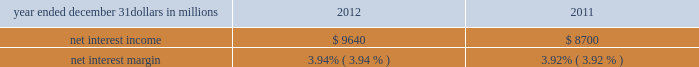Consolidated income statement review our consolidated income statement is presented in item 8 of this report .
Net income for 2012 was $ 3.0 billion compared with $ 3.1 billion for 2011 .
Revenue growth of 8 percent and a decline in the provision for credit losses were more than offset by a 16 percent increase in noninterest expense in 2012 compared to 2011 .
Further detail is included in the net interest income , noninterest income , provision for credit losses and noninterest expense portions of this consolidated income statement review .
Net interest income table 2 : net interest income and net interest margin year ended december 31 dollars in millions 2012 2011 .
Changes in net interest income and margin result from the interaction of the volume and composition of interest-earning assets and related yields , interest-bearing liabilities and related rates paid , and noninterest-bearing sources of funding .
See the statistical information ( unaudited ) 2013 average consolidated balance sheet and net interest analysis and analysis of year-to-year changes in net interest income in item 8 of this report and the discussion of purchase accounting accretion of purchased impaired loans in the consolidated balance sheet review in this item 7 for additional information .
The increase in net interest income in 2012 compared with 2011 was primarily due to the impact of the rbc bank ( usa ) acquisition , organic loan growth and lower funding costs .
Purchase accounting accretion remained stable at $ 1.1 billion in both periods .
The net interest margin was 3.94% ( 3.94 % ) for 2012 and 3.92% ( 3.92 % ) for 2011 .
The increase in the comparison was primarily due to a decrease in the weighted-average rate accrued on total interest- bearing liabilities of 29 basis points , largely offset by a 21 basis point decrease on the yield on total interest-earning assets .
The decrease in the rate on interest-bearing liabilities was primarily due to the runoff of maturing retail certificates of deposit and the redemption of additional trust preferred and hybrid capital securities during 2012 , in addition to an increase in fhlb borrowings and commercial paper as lower-cost funding sources .
The decrease in the yield on interest-earning assets was primarily due to lower rates on new loan volume and lower yields on new securities in the current low rate environment .
With respect to the first quarter of 2013 , we expect net interest income to decline by two to three percent compared to fourth quarter 2012 net interest income of $ 2.4 billion , due to a decrease in purchase accounting accretion of up to $ 50 to $ 60 million , including lower expected cash recoveries .
For the full year 2013 , we expect net interest income to decrease compared with 2012 , assuming an expected decline in purchase accounting accretion of approximately $ 400 million , while core net interest income is expected to increase in the year-over-year comparison .
We believe our net interest margin will come under pressure in 2013 , due to the expected decline in purchase accounting accretion and assuming that the current low rate environment continues .
Noninterest income noninterest income totaled $ 5.9 billion for 2012 and $ 5.6 billion for 2011 .
The overall increase in the comparison was primarily due to an increase in residential mortgage loan sales revenue driven by higher loan origination volume , gains on sales of visa class b common shares and higher corporate service fees , largely offset by higher provision for residential mortgage repurchase obligations .
Asset management revenue , including blackrock , totaled $ 1.2 billion in 2012 compared with $ 1.1 billion in 2011 .
This increase was primarily due to higher earnings from our blackrock investment .
Discretionary assets under management increased to $ 112 billion at december 31 , 2012 compared with $ 107 billion at december 31 , 2011 driven by stronger average equity markets , positive net flows and strong sales performance .
For 2012 , consumer services fees were $ 1.1 billion compared with $ 1.2 billion in 2011 .
The decline reflected the regulatory impact of lower interchange fees on debit card transactions partially offset by customer growth .
As further discussed in the retail banking portion of the business segments review section of this item 7 , the dodd-frank limits on interchange rates were effective october 1 , 2011 and had a negative impact on revenue of approximately $ 314 million in 2012 and $ 75 million in 2011 .
This impact was partially offset by higher volumes of merchant , customer credit card and debit card transactions and the impact of the rbc bank ( usa ) acquisition .
Corporate services revenue increased by $ .3 billion , or 30 percent , to $ 1.2 billion in 2012 compared with $ .9 billion in 2011 due to higher commercial mortgage servicing revenue and higher merger and acquisition advisory fees in 2012 .
The major components of corporate services revenue are treasury management revenue , corporate finance fees , including revenue from capital markets-related products and services , and commercial mortgage servicing revenue , including commercial mortgage banking activities .
See the product revenue portion of this consolidated income statement review for further detail .
The pnc financial services group , inc .
2013 form 10-k 39 .
What was the percentage change in the net interest income from 2011 to 2012? 
Computations: ((9640 - 8700) / 8700)
Answer: 0.10805. 